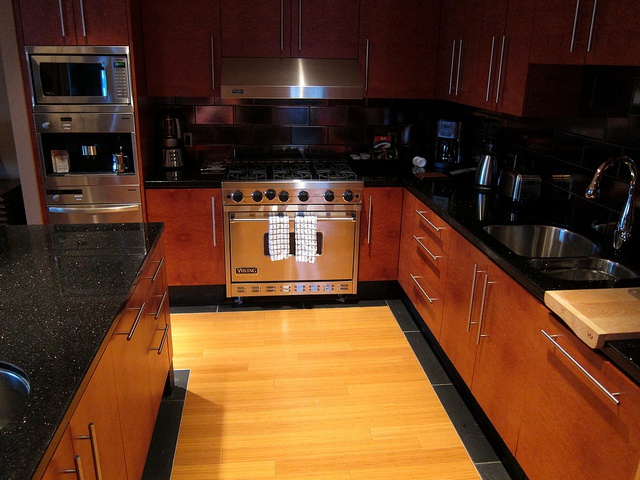Describe the objects in this image and their specific colors. I can see oven in black, red, lightgray, and gray tones, oven in black, maroon, and gray tones, microwave in black, gray, and maroon tones, sink in black, gray, and maroon tones, and sink in black and gray tones in this image. 